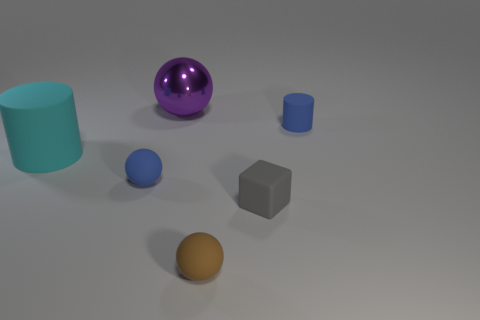There is a tiny rubber cylinder; is its color the same as the rubber sphere that is behind the tiny cube?
Give a very brief answer. Yes. Do the block and the cylinder to the left of the large ball have the same size?
Offer a terse response. No. Is there anything else that has the same material as the large purple sphere?
Offer a very short reply. No. There is a matte object that is on the right side of the rubber block; does it have the same size as the sphere that is behind the big cyan cylinder?
Make the answer very short. No. There is a sphere that is both in front of the small blue matte cylinder and to the right of the tiny blue sphere; how big is it?
Make the answer very short. Small. Does the tiny brown rubber thing have the same shape as the metal thing?
Offer a very short reply. Yes. The brown thing that is the same material as the tiny gray cube is what shape?
Make the answer very short. Sphere. How many big things are purple shiny objects or blue rubber objects?
Your answer should be compact. 1. There is a cylinder on the right side of the brown matte object; are there any metal spheres on the right side of it?
Ensure brevity in your answer.  No. Is there a tiny rubber thing?
Your answer should be compact. Yes. 